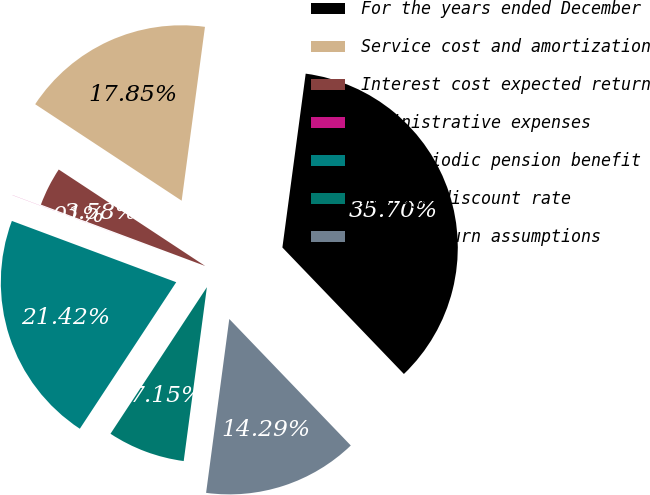Convert chart. <chart><loc_0><loc_0><loc_500><loc_500><pie_chart><fcel>For the years ended December<fcel>Service cost and amortization<fcel>Interest cost expected return<fcel>Administrative expenses<fcel>Net periodic pension benefit<fcel>Average discount rate<fcel>Asset return assumptions<nl><fcel>35.7%<fcel>17.85%<fcel>3.58%<fcel>0.01%<fcel>21.42%<fcel>7.15%<fcel>14.29%<nl></chart> 